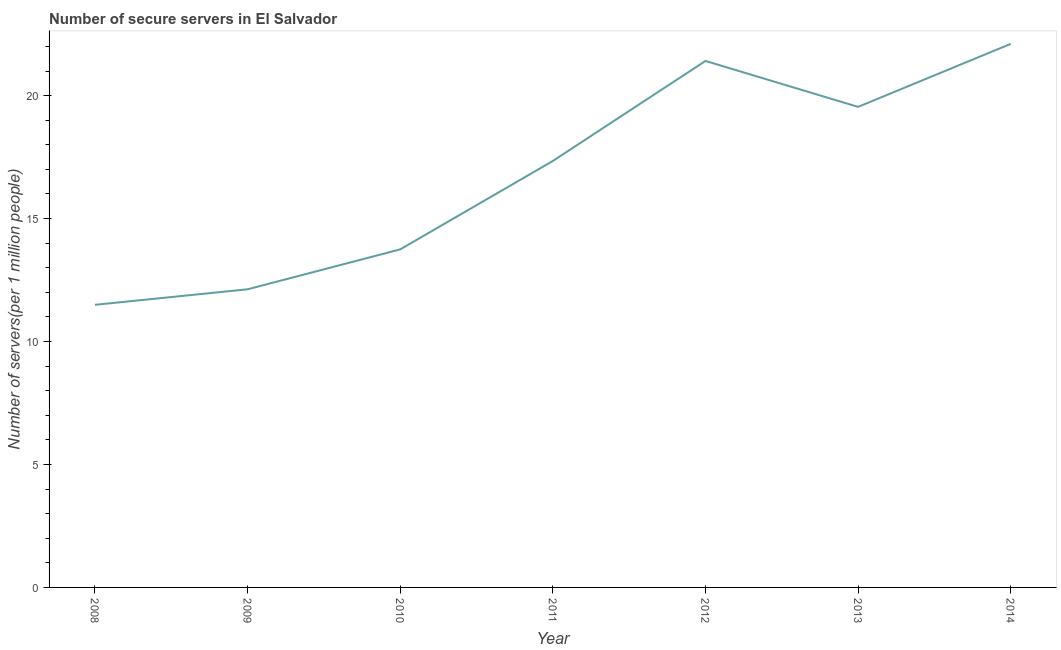What is the number of secure internet servers in 2009?
Give a very brief answer. 12.12. Across all years, what is the maximum number of secure internet servers?
Ensure brevity in your answer.  22.1. Across all years, what is the minimum number of secure internet servers?
Provide a succinct answer. 11.49. In which year was the number of secure internet servers maximum?
Make the answer very short. 2014. What is the sum of the number of secure internet servers?
Make the answer very short. 117.75. What is the difference between the number of secure internet servers in 2009 and 2013?
Provide a succinct answer. -7.42. What is the average number of secure internet servers per year?
Provide a succinct answer. 16.82. What is the median number of secure internet servers?
Make the answer very short. 17.34. What is the ratio of the number of secure internet servers in 2010 to that in 2012?
Offer a terse response. 0.64. Is the number of secure internet servers in 2009 less than that in 2011?
Provide a succinct answer. Yes. What is the difference between the highest and the second highest number of secure internet servers?
Provide a succinct answer. 0.69. Is the sum of the number of secure internet servers in 2008 and 2012 greater than the maximum number of secure internet servers across all years?
Give a very brief answer. Yes. What is the difference between the highest and the lowest number of secure internet servers?
Give a very brief answer. 10.61. In how many years, is the number of secure internet servers greater than the average number of secure internet servers taken over all years?
Provide a succinct answer. 4. Does the number of secure internet servers monotonically increase over the years?
Provide a short and direct response. No. How many lines are there?
Your answer should be very brief. 1. How many years are there in the graph?
Your response must be concise. 7. Does the graph contain any zero values?
Make the answer very short. No. Does the graph contain grids?
Your answer should be compact. No. What is the title of the graph?
Your response must be concise. Number of secure servers in El Salvador. What is the label or title of the X-axis?
Ensure brevity in your answer.  Year. What is the label or title of the Y-axis?
Ensure brevity in your answer.  Number of servers(per 1 million people). What is the Number of servers(per 1 million people) of 2008?
Give a very brief answer. 11.49. What is the Number of servers(per 1 million people) of 2009?
Your answer should be very brief. 12.12. What is the Number of servers(per 1 million people) of 2010?
Offer a terse response. 13.75. What is the Number of servers(per 1 million people) of 2011?
Keep it short and to the point. 17.34. What is the Number of servers(per 1 million people) in 2012?
Ensure brevity in your answer.  21.41. What is the Number of servers(per 1 million people) of 2013?
Keep it short and to the point. 19.54. What is the Number of servers(per 1 million people) of 2014?
Offer a terse response. 22.1. What is the difference between the Number of servers(per 1 million people) in 2008 and 2009?
Make the answer very short. -0.63. What is the difference between the Number of servers(per 1 million people) in 2008 and 2010?
Keep it short and to the point. -2.25. What is the difference between the Number of servers(per 1 million people) in 2008 and 2011?
Make the answer very short. -5.85. What is the difference between the Number of servers(per 1 million people) in 2008 and 2012?
Make the answer very short. -9.92. What is the difference between the Number of servers(per 1 million people) in 2008 and 2013?
Offer a very short reply. -8.05. What is the difference between the Number of servers(per 1 million people) in 2008 and 2014?
Keep it short and to the point. -10.61. What is the difference between the Number of servers(per 1 million people) in 2009 and 2010?
Keep it short and to the point. -1.62. What is the difference between the Number of servers(per 1 million people) in 2009 and 2011?
Provide a succinct answer. -5.22. What is the difference between the Number of servers(per 1 million people) in 2009 and 2012?
Give a very brief answer. -9.29. What is the difference between the Number of servers(per 1 million people) in 2009 and 2013?
Make the answer very short. -7.42. What is the difference between the Number of servers(per 1 million people) in 2009 and 2014?
Your answer should be compact. -9.98. What is the difference between the Number of servers(per 1 million people) in 2010 and 2011?
Give a very brief answer. -3.59. What is the difference between the Number of servers(per 1 million people) in 2010 and 2012?
Provide a short and direct response. -7.66. What is the difference between the Number of servers(per 1 million people) in 2010 and 2013?
Offer a terse response. -5.8. What is the difference between the Number of servers(per 1 million people) in 2010 and 2014?
Give a very brief answer. -8.36. What is the difference between the Number of servers(per 1 million people) in 2011 and 2012?
Make the answer very short. -4.07. What is the difference between the Number of servers(per 1 million people) in 2011 and 2013?
Your answer should be very brief. -2.2. What is the difference between the Number of servers(per 1 million people) in 2011 and 2014?
Provide a succinct answer. -4.76. What is the difference between the Number of servers(per 1 million people) in 2012 and 2013?
Your response must be concise. 1.87. What is the difference between the Number of servers(per 1 million people) in 2012 and 2014?
Make the answer very short. -0.69. What is the difference between the Number of servers(per 1 million people) in 2013 and 2014?
Your answer should be very brief. -2.56. What is the ratio of the Number of servers(per 1 million people) in 2008 to that in 2009?
Ensure brevity in your answer.  0.95. What is the ratio of the Number of servers(per 1 million people) in 2008 to that in 2010?
Your response must be concise. 0.84. What is the ratio of the Number of servers(per 1 million people) in 2008 to that in 2011?
Give a very brief answer. 0.66. What is the ratio of the Number of servers(per 1 million people) in 2008 to that in 2012?
Give a very brief answer. 0.54. What is the ratio of the Number of servers(per 1 million people) in 2008 to that in 2013?
Offer a terse response. 0.59. What is the ratio of the Number of servers(per 1 million people) in 2008 to that in 2014?
Your answer should be very brief. 0.52. What is the ratio of the Number of servers(per 1 million people) in 2009 to that in 2010?
Your answer should be very brief. 0.88. What is the ratio of the Number of servers(per 1 million people) in 2009 to that in 2011?
Your response must be concise. 0.7. What is the ratio of the Number of servers(per 1 million people) in 2009 to that in 2012?
Ensure brevity in your answer.  0.57. What is the ratio of the Number of servers(per 1 million people) in 2009 to that in 2013?
Your answer should be very brief. 0.62. What is the ratio of the Number of servers(per 1 million people) in 2009 to that in 2014?
Your answer should be very brief. 0.55. What is the ratio of the Number of servers(per 1 million people) in 2010 to that in 2011?
Ensure brevity in your answer.  0.79. What is the ratio of the Number of servers(per 1 million people) in 2010 to that in 2012?
Provide a succinct answer. 0.64. What is the ratio of the Number of servers(per 1 million people) in 2010 to that in 2013?
Provide a succinct answer. 0.7. What is the ratio of the Number of servers(per 1 million people) in 2010 to that in 2014?
Your answer should be very brief. 0.62. What is the ratio of the Number of servers(per 1 million people) in 2011 to that in 2012?
Keep it short and to the point. 0.81. What is the ratio of the Number of servers(per 1 million people) in 2011 to that in 2013?
Keep it short and to the point. 0.89. What is the ratio of the Number of servers(per 1 million people) in 2011 to that in 2014?
Offer a very short reply. 0.79. What is the ratio of the Number of servers(per 1 million people) in 2012 to that in 2013?
Make the answer very short. 1.1. What is the ratio of the Number of servers(per 1 million people) in 2012 to that in 2014?
Your response must be concise. 0.97. What is the ratio of the Number of servers(per 1 million people) in 2013 to that in 2014?
Offer a terse response. 0.88. 